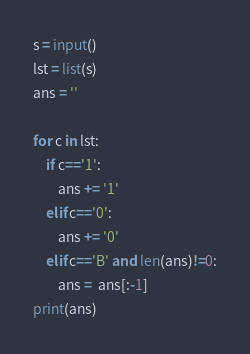Convert code to text. <code><loc_0><loc_0><loc_500><loc_500><_Python_>s = input()
lst = list(s)
ans = ''

for c in lst:
    if c=='1':
        ans += '1'
    elif c=='0':
        ans += '0'
    elif c=='B' and len(ans)!=0:
        ans =  ans[:-1]
print(ans)</code> 